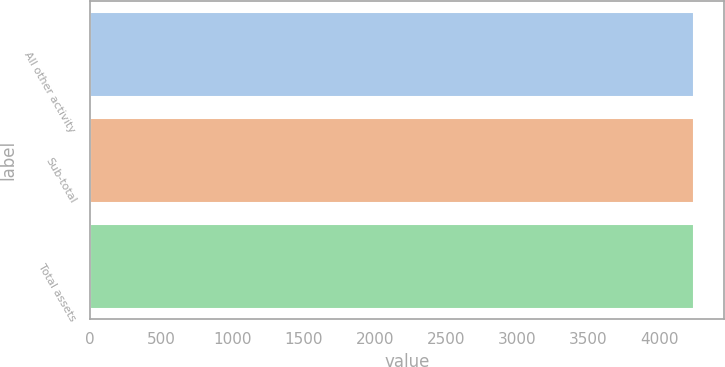Convert chart to OTSL. <chart><loc_0><loc_0><loc_500><loc_500><bar_chart><fcel>All other activity<fcel>Sub-total<fcel>Total assets<nl><fcel>4242<fcel>4242.1<fcel>4242.2<nl></chart> 